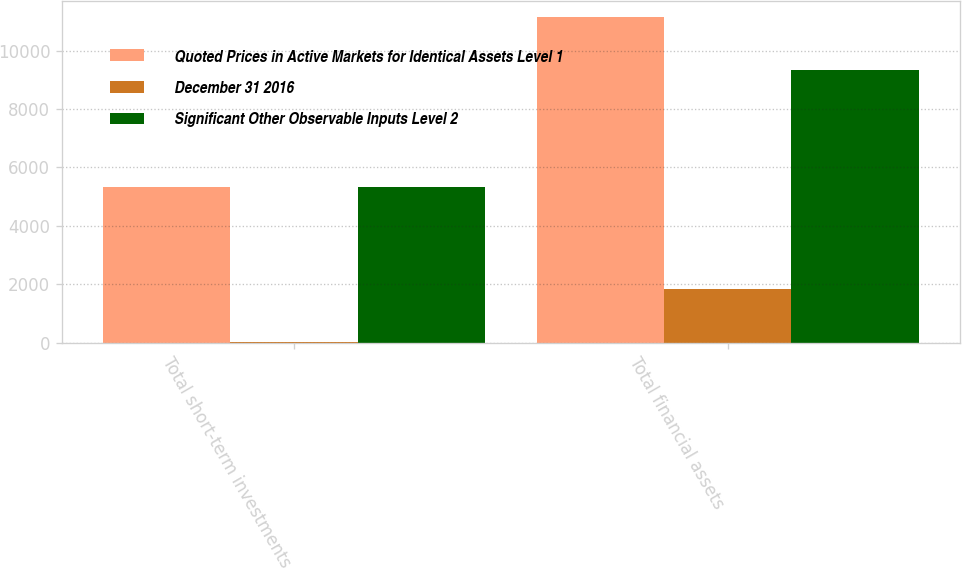Convert chart to OTSL. <chart><loc_0><loc_0><loc_500><loc_500><stacked_bar_chart><ecel><fcel>Total short-term investments<fcel>Total financial assets<nl><fcel>Quoted Prices in Active Markets for Identical Assets Level 1<fcel>5333<fcel>11154<nl><fcel>December 31 2016<fcel>19<fcel>1835<nl><fcel>Significant Other Observable Inputs Level 2<fcel>5314<fcel>9319<nl></chart> 